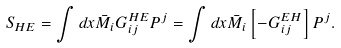<formula> <loc_0><loc_0><loc_500><loc_500>S _ { H E } = \int d x \bar { M } _ { i } G _ { i j } ^ { H E } P ^ { j } = \int d x \bar { M } _ { i } \left [ - G _ { i j } ^ { E H } \right ] P ^ { j } .</formula> 